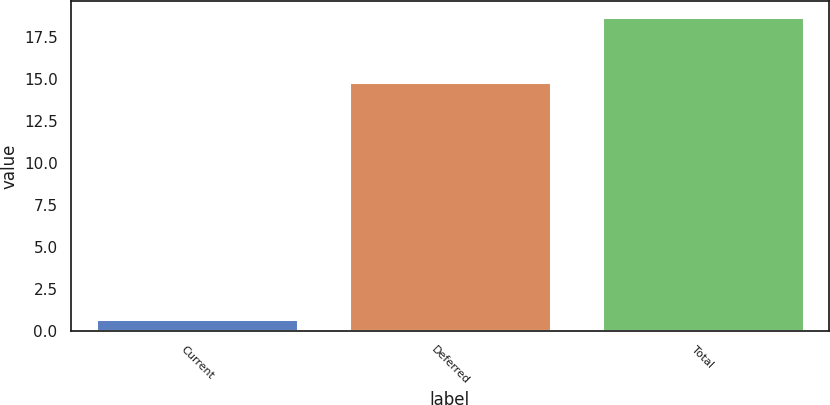Convert chart to OTSL. <chart><loc_0><loc_0><loc_500><loc_500><bar_chart><fcel>Current<fcel>Deferred<fcel>Total<nl><fcel>0.7<fcel>14.8<fcel>18.7<nl></chart> 